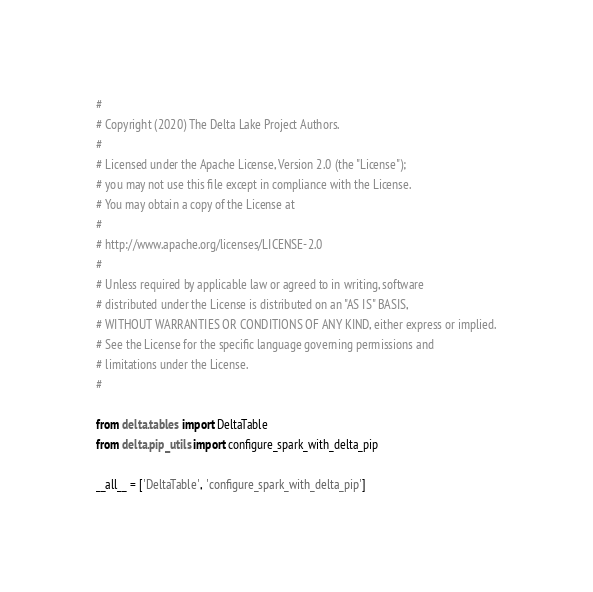Convert code to text. <code><loc_0><loc_0><loc_500><loc_500><_Python_>#
# Copyright (2020) The Delta Lake Project Authors.
#
# Licensed under the Apache License, Version 2.0 (the "License");
# you may not use this file except in compliance with the License.
# You may obtain a copy of the License at
#
# http://www.apache.org/licenses/LICENSE-2.0
#
# Unless required by applicable law or agreed to in writing, software
# distributed under the License is distributed on an "AS IS" BASIS,
# WITHOUT WARRANTIES OR CONDITIONS OF ANY KIND, either express or implied.
# See the License for the specific language governing permissions and
# limitations under the License.
#

from delta.tables import DeltaTable
from delta.pip_utils import configure_spark_with_delta_pip

__all__ = ['DeltaTable', 'configure_spark_with_delta_pip']
</code> 